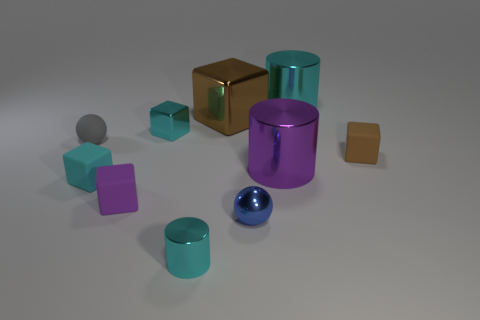Subtract all metal cubes. How many cubes are left? 3 Subtract all cylinders. How many objects are left? 7 Subtract all green spheres. Subtract all yellow cylinders. How many spheres are left? 2 Subtract all blue balls. How many purple cylinders are left? 1 Subtract all blue shiny objects. Subtract all tiny cyan cubes. How many objects are left? 7 Add 5 purple objects. How many purple objects are left? 7 Add 9 purple blocks. How many purple blocks exist? 10 Subtract all cyan cylinders. How many cylinders are left? 1 Subtract 0 green blocks. How many objects are left? 10 Subtract 1 cylinders. How many cylinders are left? 2 